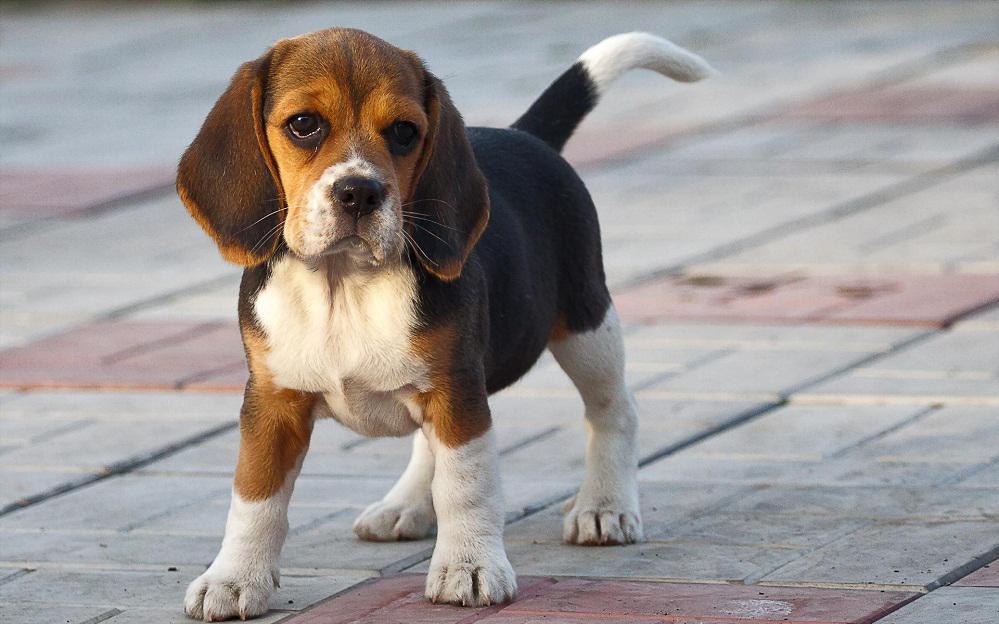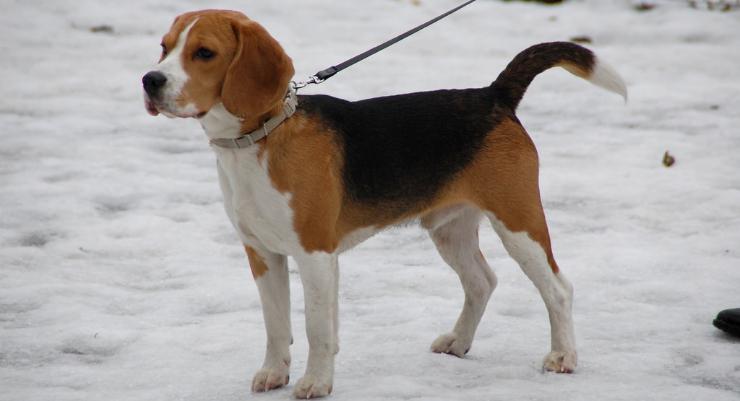The first image is the image on the left, the second image is the image on the right. For the images displayed, is the sentence "There is an image of a tan and white puppy sitting on grass." factually correct? Answer yes or no. No. The first image is the image on the left, the second image is the image on the right. For the images shown, is this caption "the right image has a puppy on a grassy surface" true? Answer yes or no. No. 